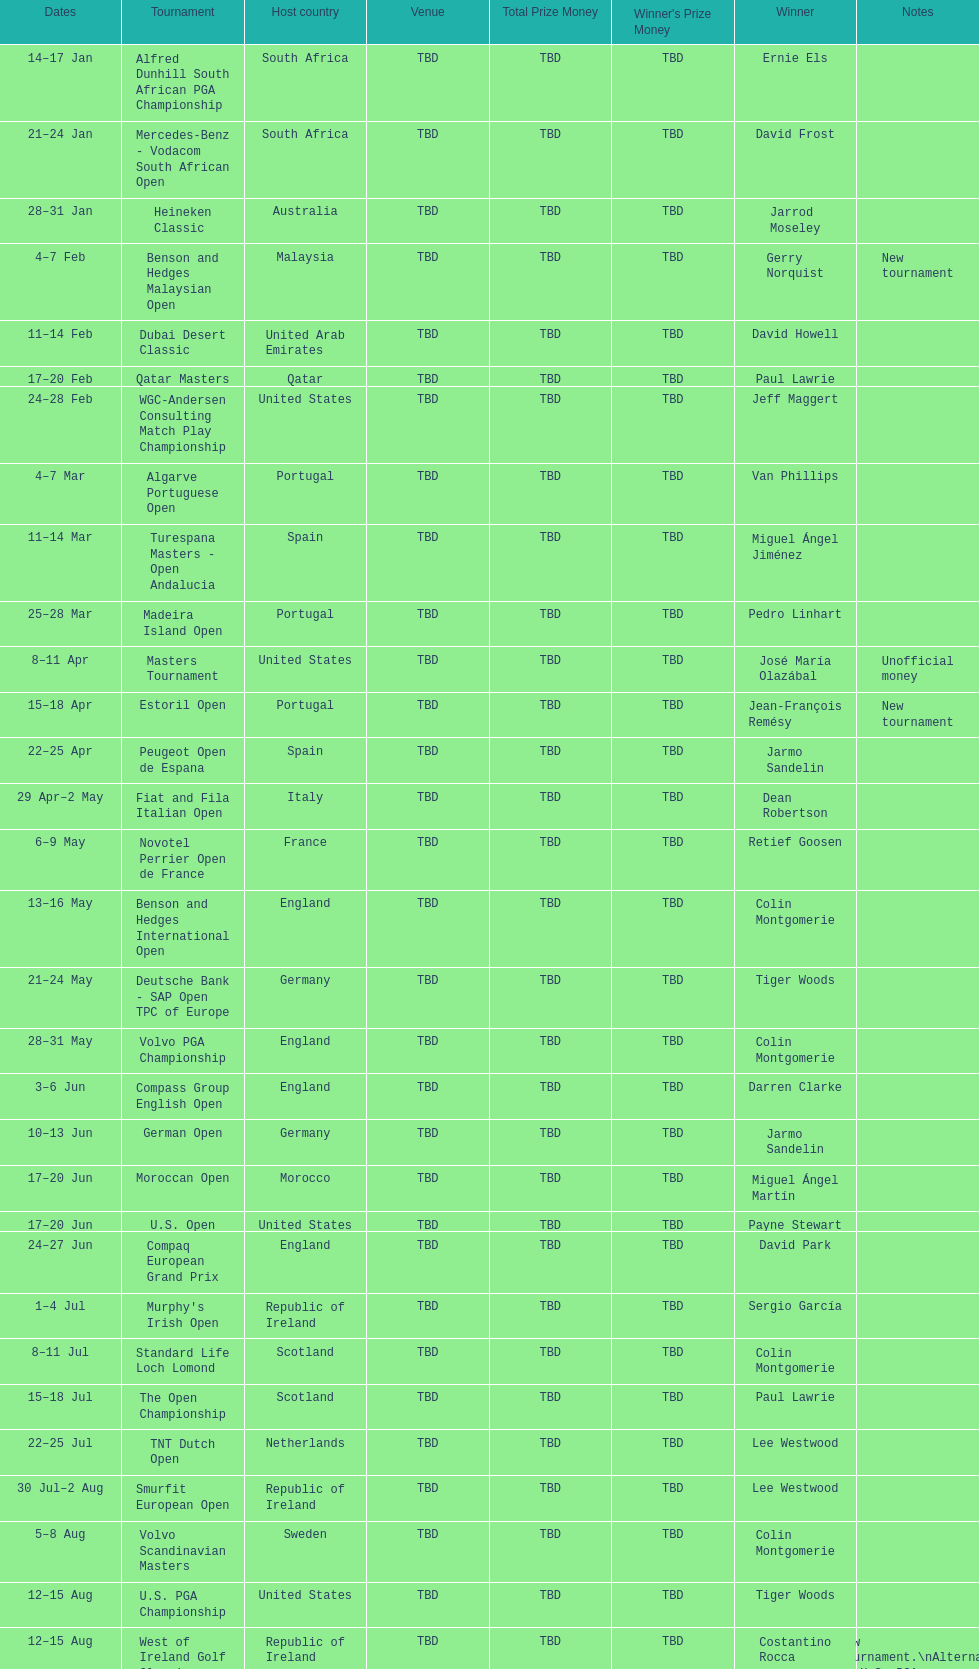How many consecutive times was south africa the host country? 2. 